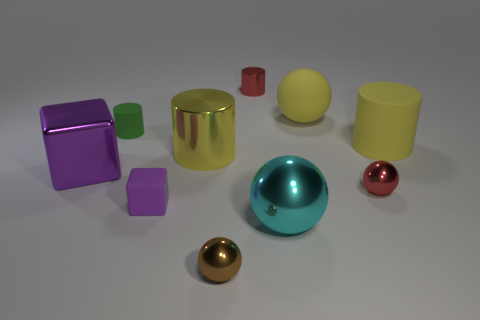Subtract all large matte cylinders. How many cylinders are left? 3 Subtract all yellow cylinders. How many cylinders are left? 2 Subtract all shiny things. Subtract all purple shiny objects. How many objects are left? 3 Add 3 tiny brown balls. How many tiny brown balls are left? 4 Add 6 tiny blue rubber balls. How many tiny blue rubber balls exist? 6 Subtract 0 red cubes. How many objects are left? 10 Subtract all cubes. How many objects are left? 8 Subtract 1 blocks. How many blocks are left? 1 Subtract all red cylinders. Subtract all gray blocks. How many cylinders are left? 3 Subtract all blue blocks. How many red spheres are left? 1 